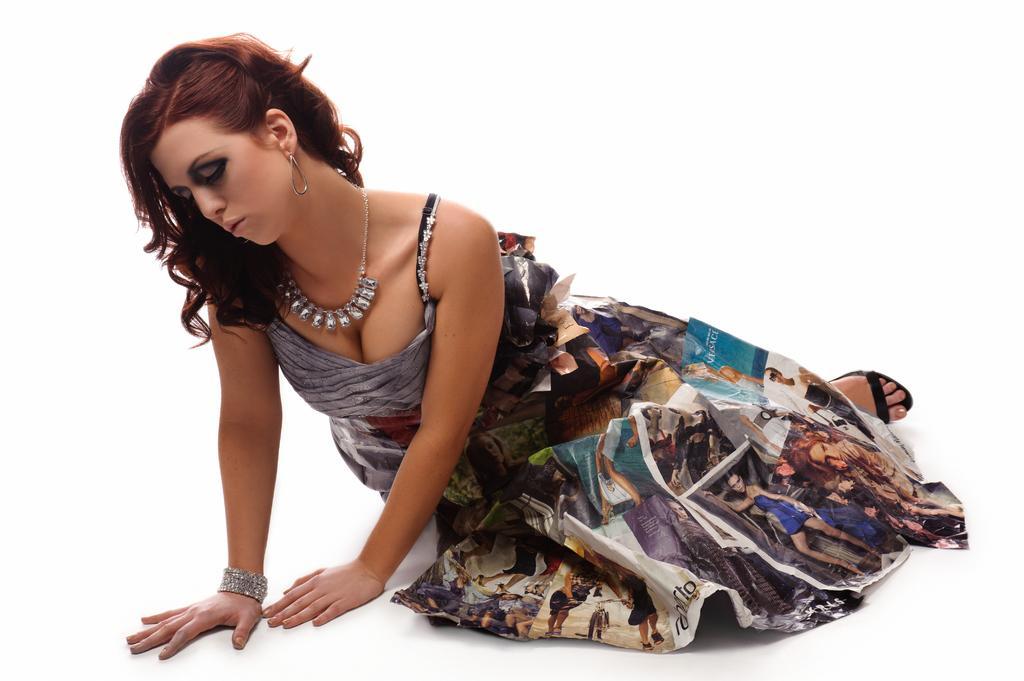Describe this image in one or two sentences. In the center of the image there is a lady. 